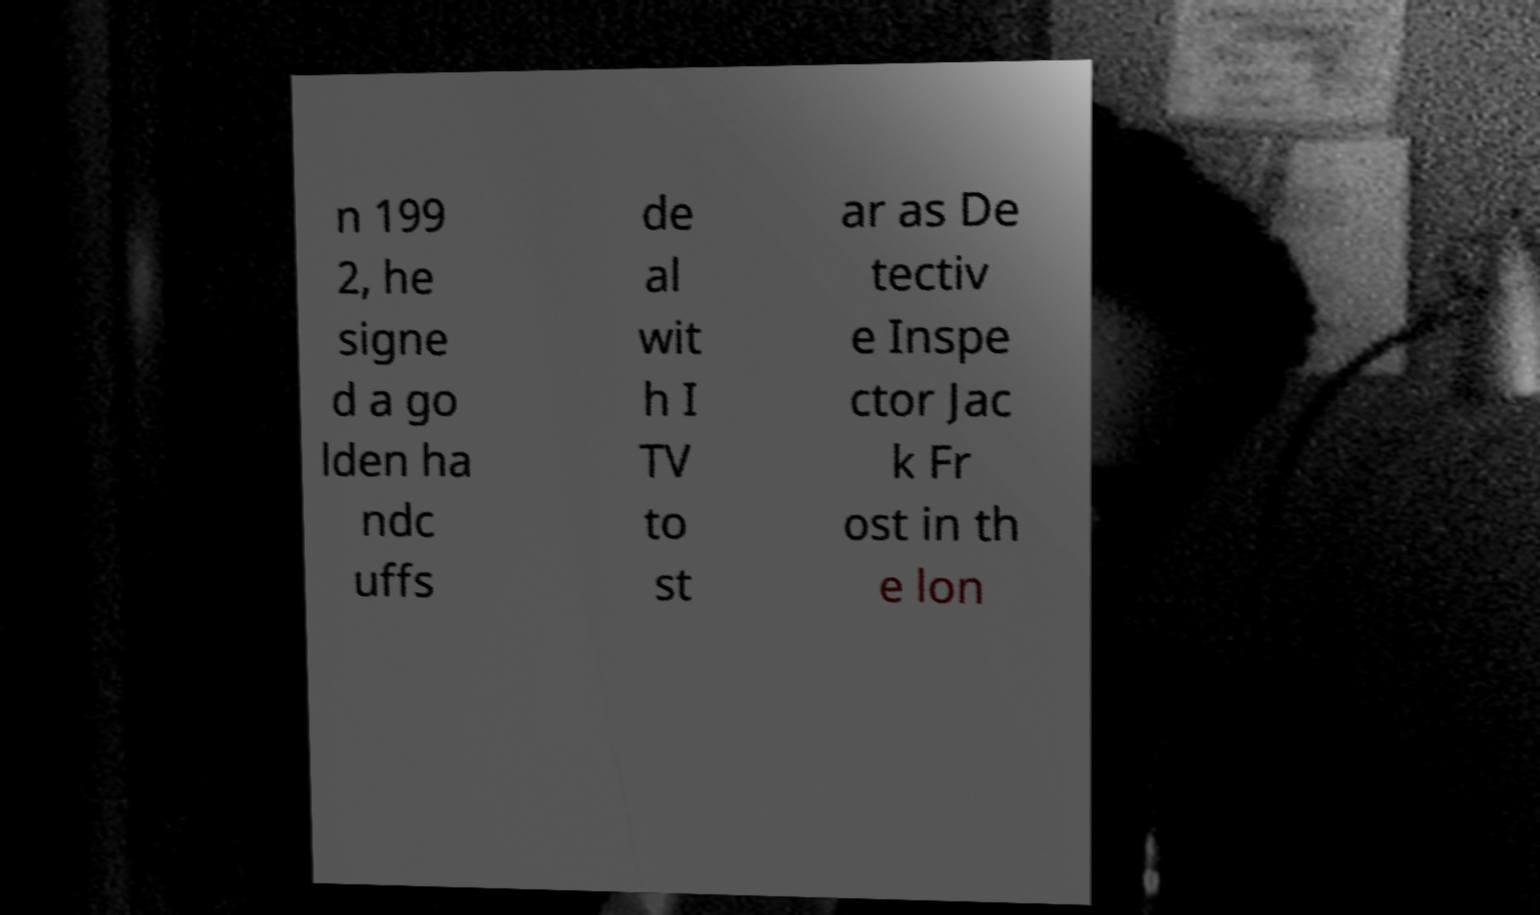Could you assist in decoding the text presented in this image and type it out clearly? n 199 2, he signe d a go lden ha ndc uffs de al wit h I TV to st ar as De tectiv e Inspe ctor Jac k Fr ost in th e lon 